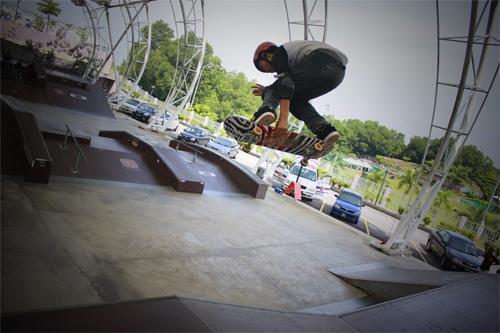How many wheels are on the board?
Give a very brief answer. 4. How many skaters are in the shot?
Give a very brief answer. 1. How many people are playing football?
Give a very brief answer. 0. 